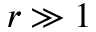<formula> <loc_0><loc_0><loc_500><loc_500>r \gg 1</formula> 